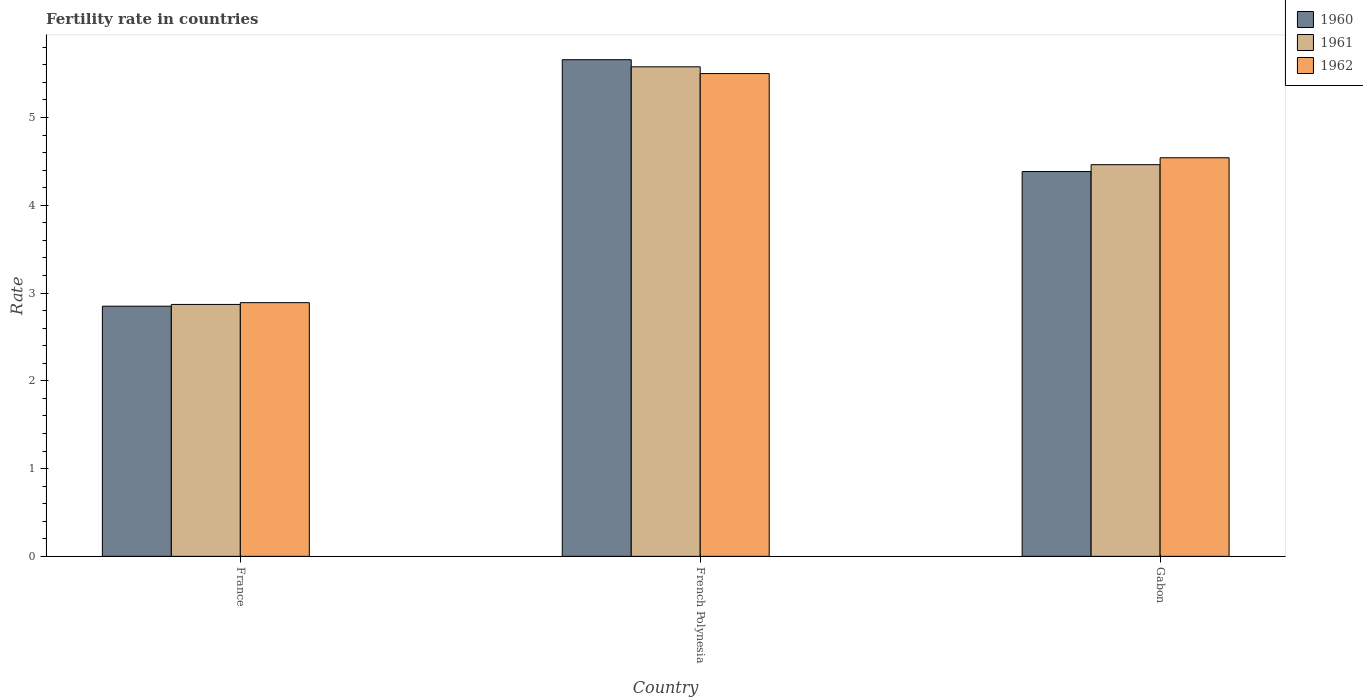How many groups of bars are there?
Give a very brief answer. 3. How many bars are there on the 3rd tick from the right?
Your response must be concise. 3. What is the label of the 1st group of bars from the left?
Ensure brevity in your answer.  France. In how many cases, is the number of bars for a given country not equal to the number of legend labels?
Provide a short and direct response. 0. What is the fertility rate in 1962 in France?
Offer a very short reply. 2.89. Across all countries, what is the maximum fertility rate in 1961?
Make the answer very short. 5.58. Across all countries, what is the minimum fertility rate in 1961?
Provide a short and direct response. 2.87. In which country was the fertility rate in 1960 maximum?
Ensure brevity in your answer.  French Polynesia. In which country was the fertility rate in 1960 minimum?
Offer a terse response. France. What is the total fertility rate in 1962 in the graph?
Keep it short and to the point. 12.93. What is the difference between the fertility rate in 1960 in France and that in Gabon?
Make the answer very short. -1.53. What is the difference between the fertility rate in 1962 in France and the fertility rate in 1960 in French Polynesia?
Your answer should be very brief. -2.77. What is the average fertility rate in 1961 per country?
Ensure brevity in your answer.  4.3. What is the difference between the fertility rate of/in 1962 and fertility rate of/in 1961 in Gabon?
Your response must be concise. 0.08. What is the ratio of the fertility rate in 1961 in French Polynesia to that in Gabon?
Make the answer very short. 1.25. Is the difference between the fertility rate in 1962 in France and French Polynesia greater than the difference between the fertility rate in 1961 in France and French Polynesia?
Ensure brevity in your answer.  Yes. What is the difference between the highest and the second highest fertility rate in 1961?
Your answer should be compact. -1.59. What is the difference between the highest and the lowest fertility rate in 1960?
Give a very brief answer. 2.81. Is the sum of the fertility rate in 1962 in French Polynesia and Gabon greater than the maximum fertility rate in 1961 across all countries?
Keep it short and to the point. Yes. What does the 2nd bar from the left in French Polynesia represents?
Your response must be concise. 1961. Is it the case that in every country, the sum of the fertility rate in 1962 and fertility rate in 1961 is greater than the fertility rate in 1960?
Make the answer very short. Yes. Are all the bars in the graph horizontal?
Keep it short and to the point. No. How many countries are there in the graph?
Your answer should be very brief. 3. Where does the legend appear in the graph?
Provide a succinct answer. Top right. How are the legend labels stacked?
Your answer should be compact. Vertical. What is the title of the graph?
Offer a terse response. Fertility rate in countries. Does "1999" appear as one of the legend labels in the graph?
Keep it short and to the point. No. What is the label or title of the X-axis?
Provide a succinct answer. Country. What is the label or title of the Y-axis?
Keep it short and to the point. Rate. What is the Rate of 1960 in France?
Provide a succinct answer. 2.85. What is the Rate in 1961 in France?
Your answer should be very brief. 2.87. What is the Rate in 1962 in France?
Your answer should be compact. 2.89. What is the Rate of 1960 in French Polynesia?
Give a very brief answer. 5.66. What is the Rate in 1961 in French Polynesia?
Ensure brevity in your answer.  5.58. What is the Rate in 1962 in French Polynesia?
Give a very brief answer. 5.5. What is the Rate of 1960 in Gabon?
Provide a short and direct response. 4.38. What is the Rate in 1961 in Gabon?
Ensure brevity in your answer.  4.46. What is the Rate of 1962 in Gabon?
Your answer should be very brief. 4.54. Across all countries, what is the maximum Rate of 1960?
Make the answer very short. 5.66. Across all countries, what is the maximum Rate of 1961?
Offer a very short reply. 5.58. Across all countries, what is the maximum Rate of 1962?
Keep it short and to the point. 5.5. Across all countries, what is the minimum Rate in 1960?
Give a very brief answer. 2.85. Across all countries, what is the minimum Rate in 1961?
Your response must be concise. 2.87. Across all countries, what is the minimum Rate in 1962?
Offer a very short reply. 2.89. What is the total Rate of 1960 in the graph?
Keep it short and to the point. 12.89. What is the total Rate of 1961 in the graph?
Keep it short and to the point. 12.91. What is the total Rate in 1962 in the graph?
Ensure brevity in your answer.  12.93. What is the difference between the Rate of 1960 in France and that in French Polynesia?
Your answer should be compact. -2.81. What is the difference between the Rate of 1961 in France and that in French Polynesia?
Keep it short and to the point. -2.71. What is the difference between the Rate of 1962 in France and that in French Polynesia?
Ensure brevity in your answer.  -2.61. What is the difference between the Rate in 1960 in France and that in Gabon?
Your answer should be compact. -1.53. What is the difference between the Rate in 1961 in France and that in Gabon?
Give a very brief answer. -1.59. What is the difference between the Rate in 1962 in France and that in Gabon?
Provide a succinct answer. -1.65. What is the difference between the Rate of 1960 in French Polynesia and that in Gabon?
Keep it short and to the point. 1.27. What is the difference between the Rate of 1961 in French Polynesia and that in Gabon?
Provide a short and direct response. 1.11. What is the difference between the Rate in 1960 in France and the Rate in 1961 in French Polynesia?
Give a very brief answer. -2.73. What is the difference between the Rate in 1960 in France and the Rate in 1962 in French Polynesia?
Provide a succinct answer. -2.65. What is the difference between the Rate in 1961 in France and the Rate in 1962 in French Polynesia?
Offer a terse response. -2.63. What is the difference between the Rate of 1960 in France and the Rate of 1961 in Gabon?
Ensure brevity in your answer.  -1.61. What is the difference between the Rate of 1960 in France and the Rate of 1962 in Gabon?
Your answer should be compact. -1.69. What is the difference between the Rate in 1961 in France and the Rate in 1962 in Gabon?
Offer a terse response. -1.67. What is the difference between the Rate of 1960 in French Polynesia and the Rate of 1961 in Gabon?
Provide a succinct answer. 1.2. What is the difference between the Rate of 1960 in French Polynesia and the Rate of 1962 in Gabon?
Offer a terse response. 1.12. What is the difference between the Rate in 1961 in French Polynesia and the Rate in 1962 in Gabon?
Your answer should be compact. 1.04. What is the average Rate of 1960 per country?
Provide a succinct answer. 4.3. What is the average Rate in 1961 per country?
Your answer should be very brief. 4.3. What is the average Rate in 1962 per country?
Your answer should be very brief. 4.31. What is the difference between the Rate of 1960 and Rate of 1961 in France?
Provide a succinct answer. -0.02. What is the difference between the Rate in 1960 and Rate in 1962 in France?
Ensure brevity in your answer.  -0.04. What is the difference between the Rate of 1961 and Rate of 1962 in France?
Keep it short and to the point. -0.02. What is the difference between the Rate in 1960 and Rate in 1961 in French Polynesia?
Offer a very short reply. 0.08. What is the difference between the Rate in 1960 and Rate in 1962 in French Polynesia?
Make the answer very short. 0.16. What is the difference between the Rate in 1961 and Rate in 1962 in French Polynesia?
Provide a succinct answer. 0.08. What is the difference between the Rate of 1960 and Rate of 1961 in Gabon?
Your response must be concise. -0.08. What is the difference between the Rate of 1960 and Rate of 1962 in Gabon?
Provide a succinct answer. -0.16. What is the difference between the Rate of 1961 and Rate of 1962 in Gabon?
Your answer should be very brief. -0.08. What is the ratio of the Rate of 1960 in France to that in French Polynesia?
Your response must be concise. 0.5. What is the ratio of the Rate in 1961 in France to that in French Polynesia?
Make the answer very short. 0.51. What is the ratio of the Rate of 1962 in France to that in French Polynesia?
Your response must be concise. 0.53. What is the ratio of the Rate of 1960 in France to that in Gabon?
Provide a short and direct response. 0.65. What is the ratio of the Rate in 1961 in France to that in Gabon?
Your response must be concise. 0.64. What is the ratio of the Rate in 1962 in France to that in Gabon?
Make the answer very short. 0.64. What is the ratio of the Rate of 1960 in French Polynesia to that in Gabon?
Ensure brevity in your answer.  1.29. What is the ratio of the Rate in 1961 in French Polynesia to that in Gabon?
Your answer should be compact. 1.25. What is the ratio of the Rate of 1962 in French Polynesia to that in Gabon?
Your answer should be compact. 1.21. What is the difference between the highest and the second highest Rate in 1960?
Your answer should be compact. 1.27. What is the difference between the highest and the second highest Rate of 1961?
Offer a terse response. 1.11. What is the difference between the highest and the second highest Rate of 1962?
Make the answer very short. 0.96. What is the difference between the highest and the lowest Rate of 1960?
Make the answer very short. 2.81. What is the difference between the highest and the lowest Rate of 1961?
Provide a short and direct response. 2.71. What is the difference between the highest and the lowest Rate in 1962?
Make the answer very short. 2.61. 